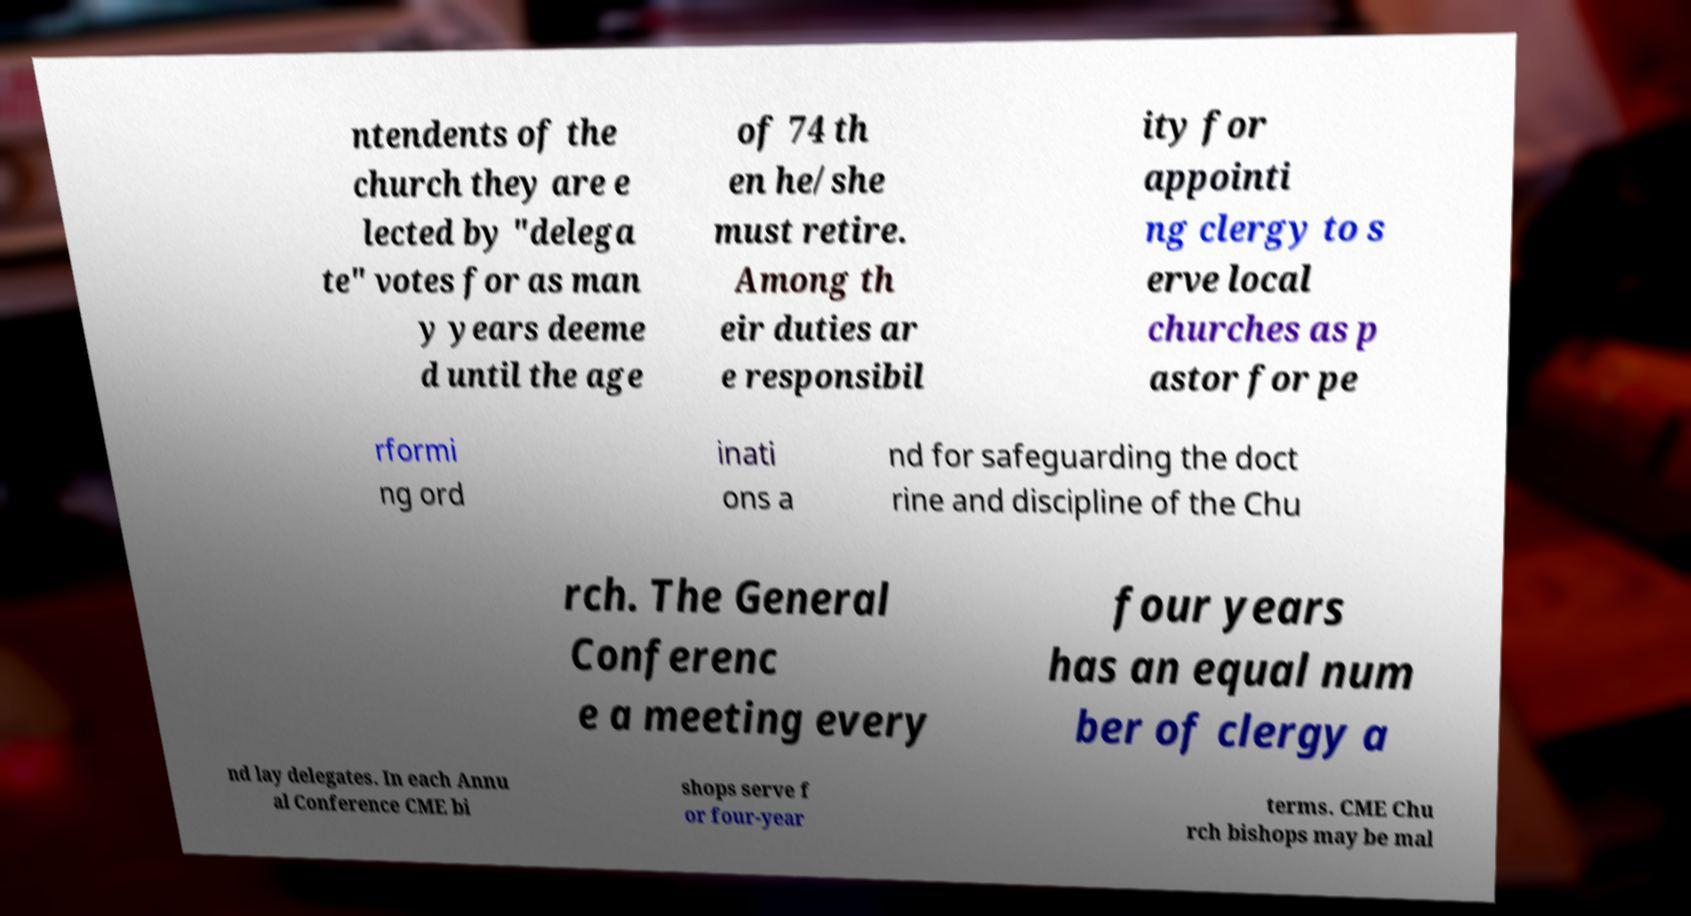Please identify and transcribe the text found in this image. ntendents of the church they are e lected by "delega te" votes for as man y years deeme d until the age of 74 th en he/she must retire. Among th eir duties ar e responsibil ity for appointi ng clergy to s erve local churches as p astor for pe rformi ng ord inati ons a nd for safeguarding the doct rine and discipline of the Chu rch. The General Conferenc e a meeting every four years has an equal num ber of clergy a nd lay delegates. In each Annu al Conference CME bi shops serve f or four-year terms. CME Chu rch bishops may be mal 